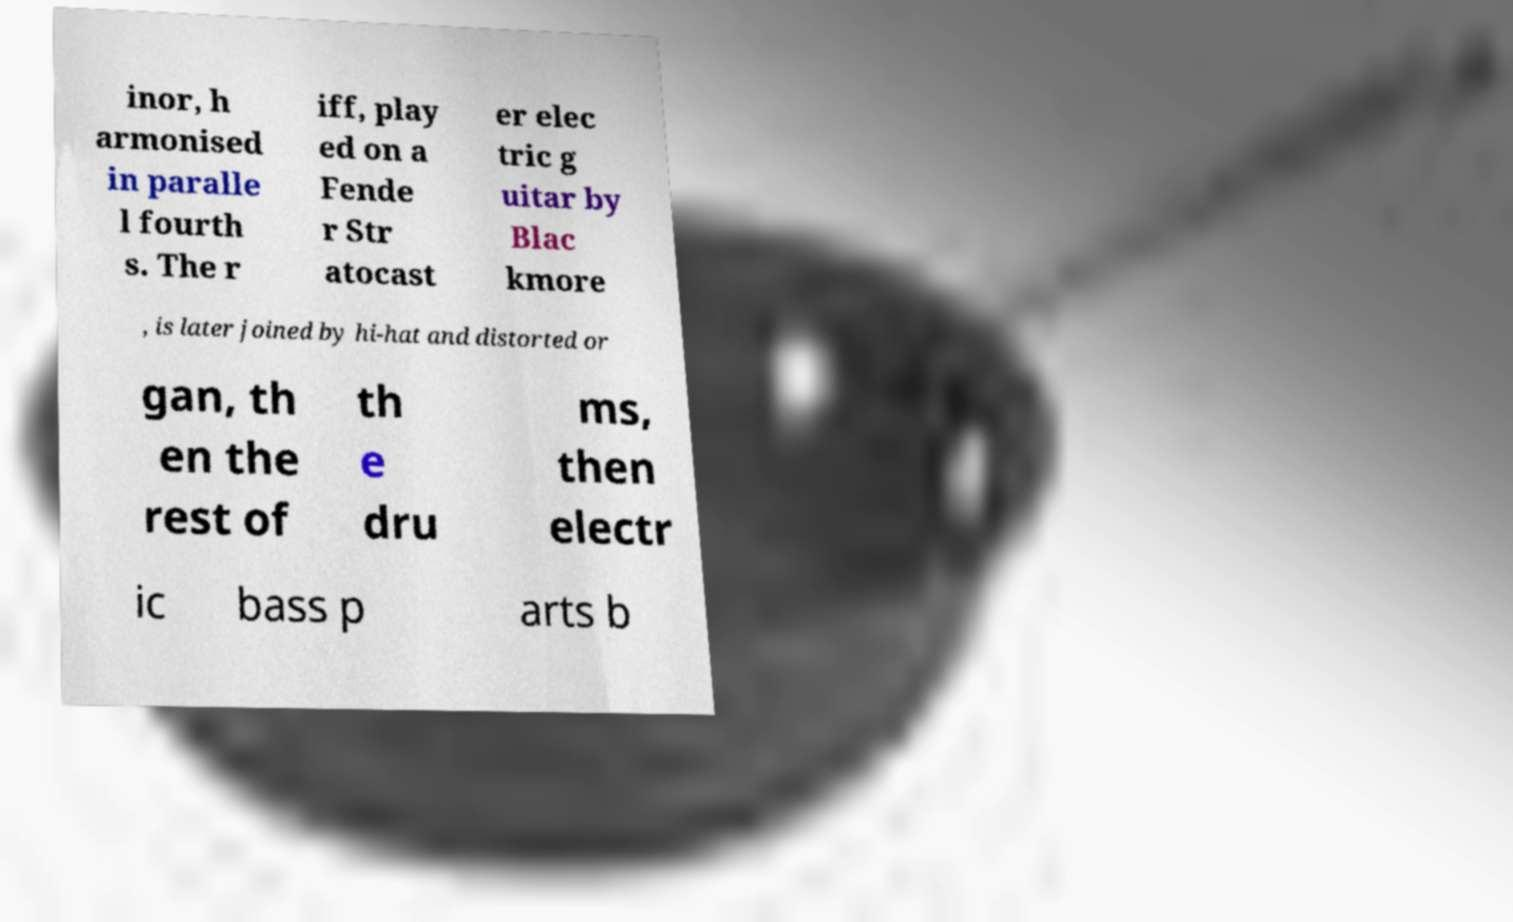There's text embedded in this image that I need extracted. Can you transcribe it verbatim? inor, h armonised in paralle l fourth s. The r iff, play ed on a Fende r Str atocast er elec tric g uitar by Blac kmore , is later joined by hi-hat and distorted or gan, th en the rest of th e dru ms, then electr ic bass p arts b 